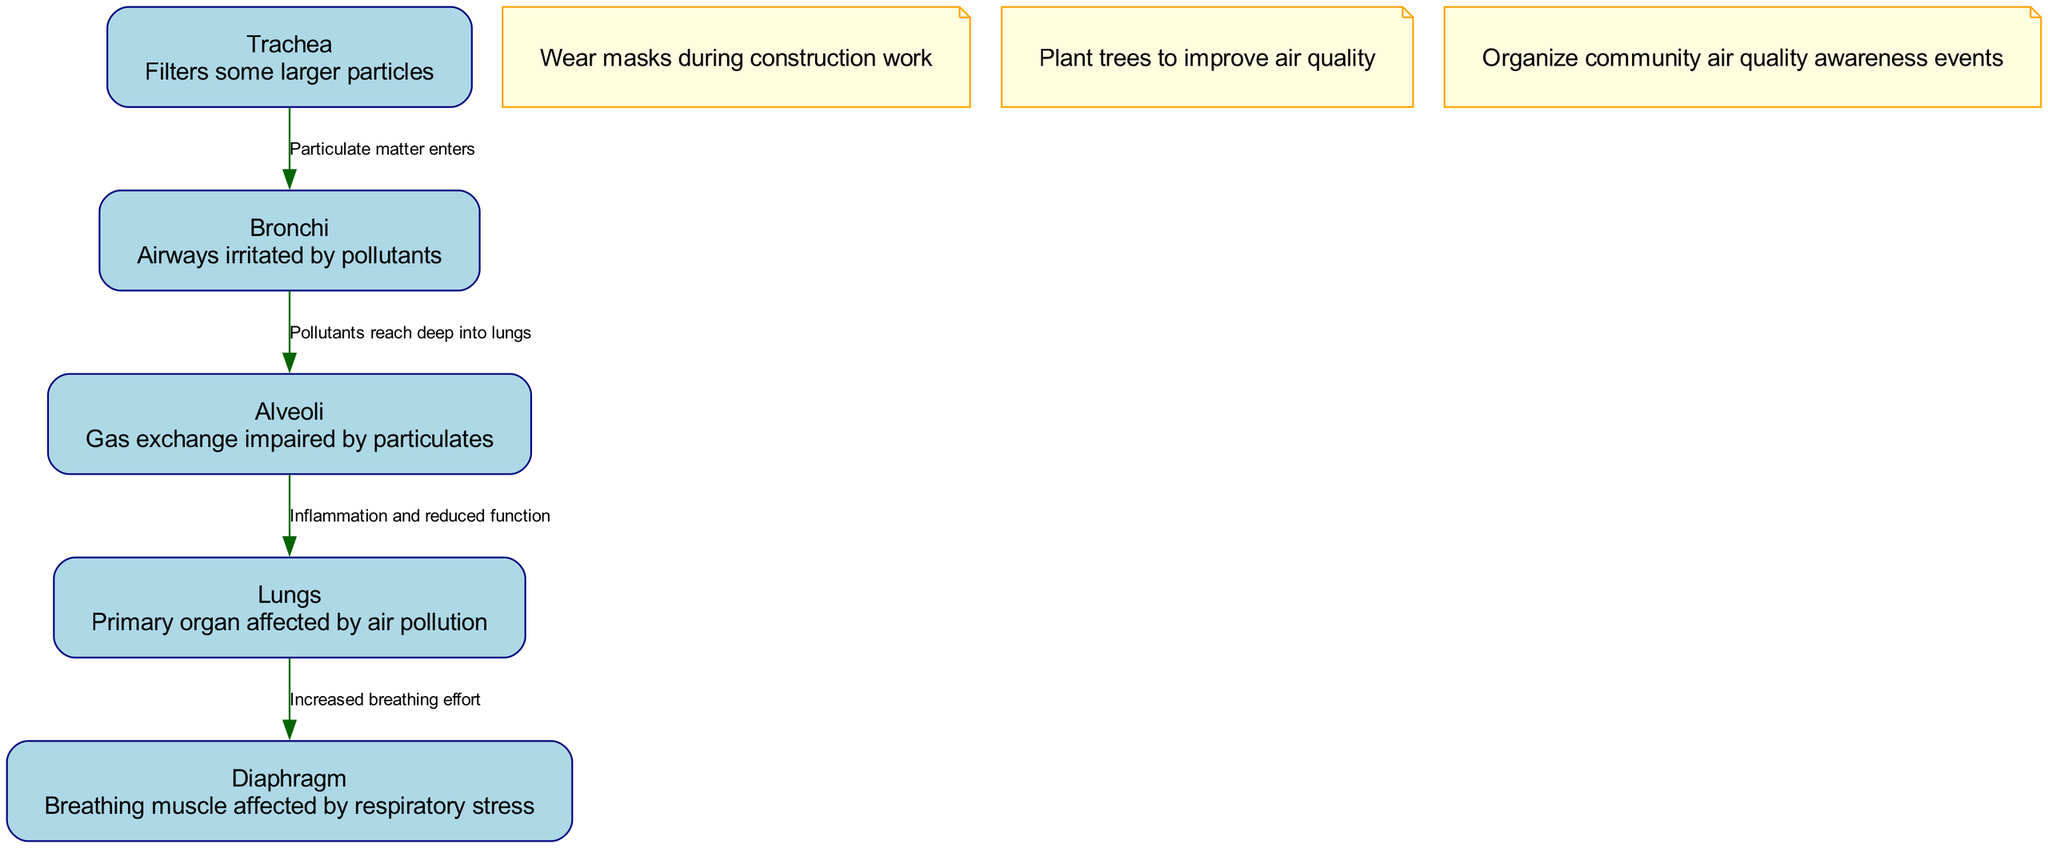What is the primary organ affected by air pollution? The diagram indicates that the "Lungs" is the primary organ affected by air pollution, as it is labeled clearly in the diagram.
Answer: Lungs How many nodes are shown in the diagram? By counting the listed nodes in the data, there are a total of five nodes: Lungs, Bronchi, Alveoli, Trachea, and Diaphragm.
Answer: 5 What relationship is described between the trachea and the bronchi? The diagram shows that "Particulate matter enters" from the Trachea to the Bronchi, indicating that pollutants move into the bronchi through this relationship.
Answer: Particulate matter enters Which node is listed as the site where gas exchange is impaired? The "Alveoli" node is described in the diagram as the site where "Gas exchange impaired by particulates" occurs, indicating its vulnerability to air pollution.
Answer: Alveoli What effect does air pollution have on the diaphragm according to the diagram? The diagram describes that the diaphragm experiences "Increased breathing effort" as a consequence of air pollution effects on the lungs.
Answer: Increased breathing effort What action is suggested for improving air quality according to the annotations? The diagram includes an annotation that suggests "Plant trees to improve air quality," indicating a community action to combat pollution.
Answer: Plant trees to improve air quality What is the relationship between bronchi and alveoli? The label "Pollutants reach deep into lungs" represents the relationship, showing that pollutants from the bronchi move towards the alveoli, indicating the severity of pollution's impact on deeper lung structures.
Answer: Pollutants reach deep into lungs What type of stress does air pollution induce on the diaphragm? The diagram indicates that air pollution induces "respiratory stress" on the diaphragm, linking it to the overall impact on breathing.
Answer: Respiratory stress 